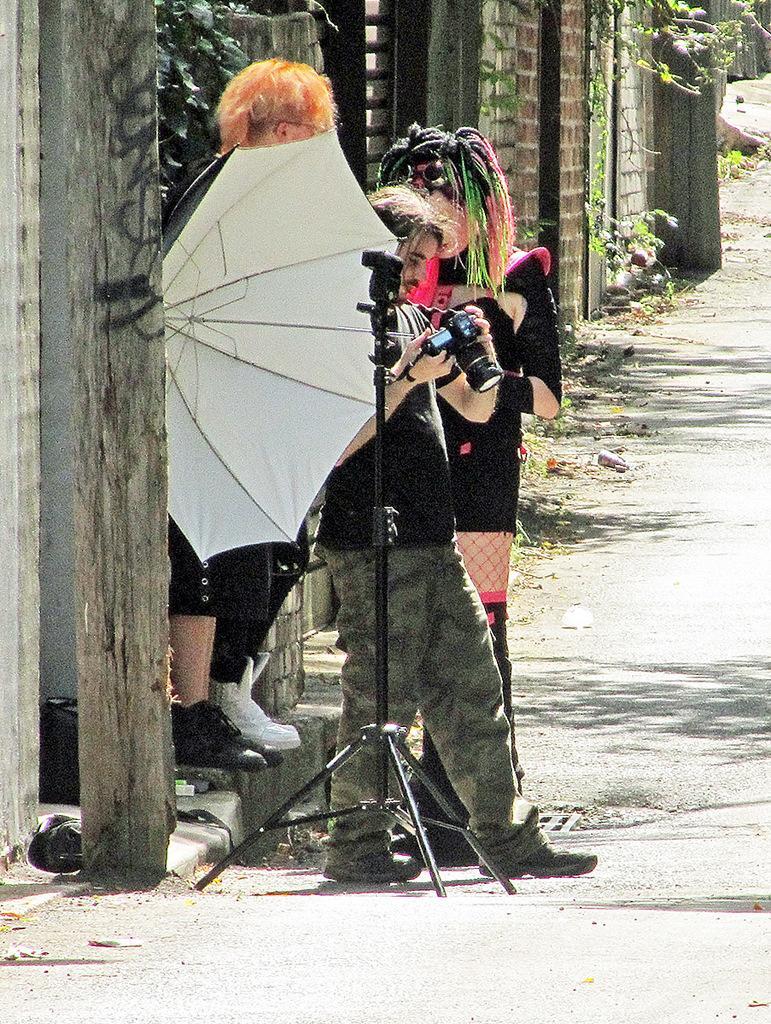Can you describe this image briefly? There are three people standing. This man is holding a camera. I think this is an umbrella. This looks like a tripod stand. Here is a wall. This looks like a wooden pillar. I can see the plants. This is the road. 